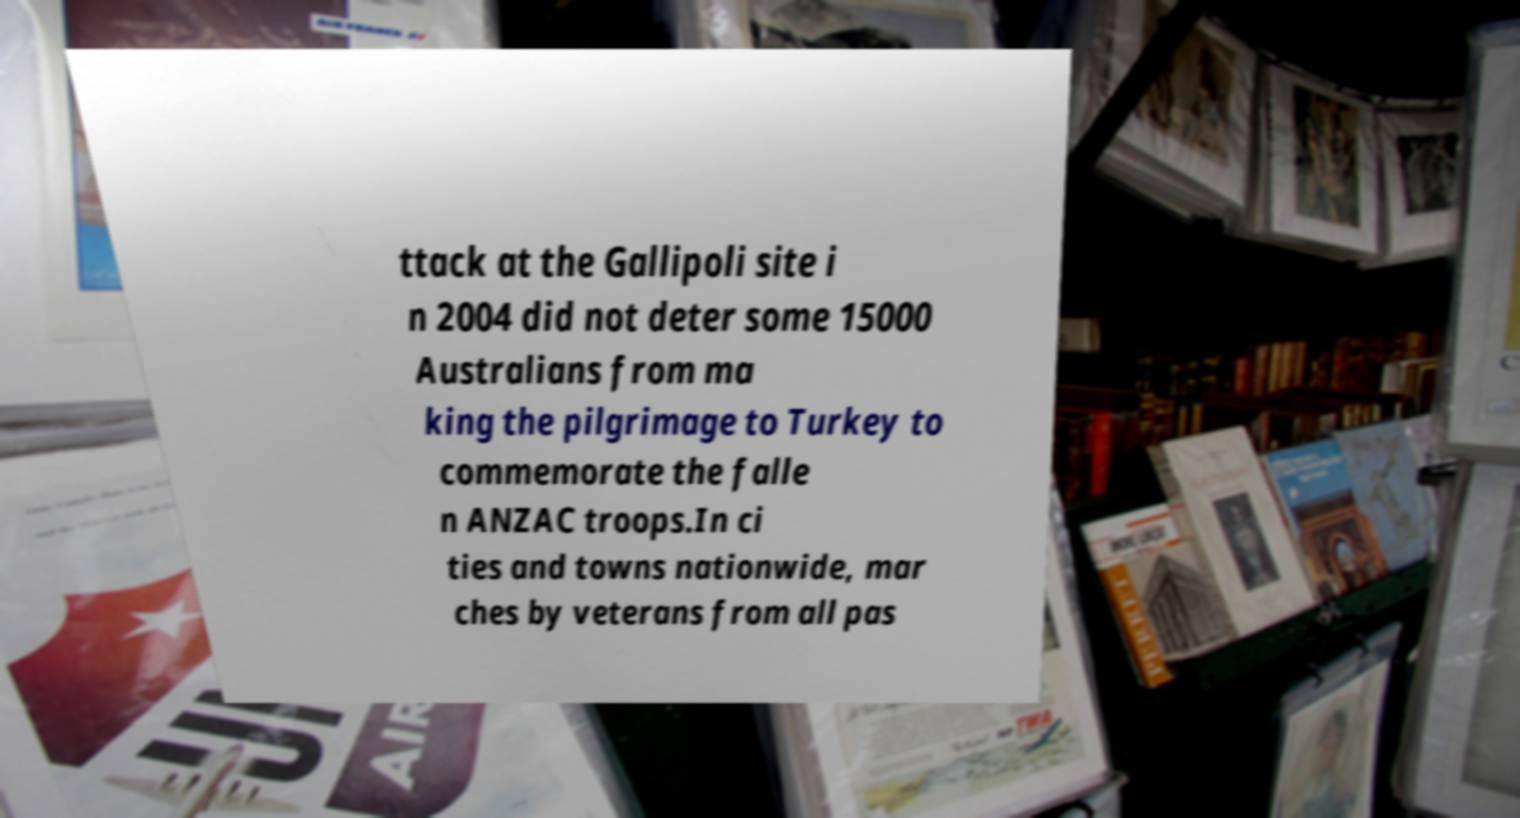What messages or text are displayed in this image? I need them in a readable, typed format. ttack at the Gallipoli site i n 2004 did not deter some 15000 Australians from ma king the pilgrimage to Turkey to commemorate the falle n ANZAC troops.In ci ties and towns nationwide, mar ches by veterans from all pas 